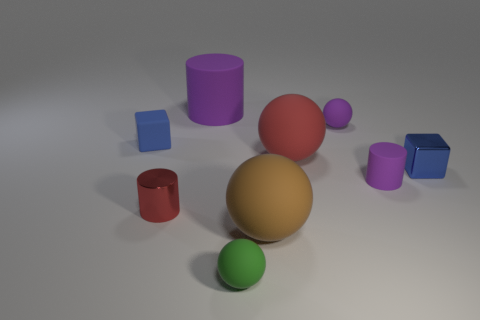Does the red ball have the same size as the brown object?
Your answer should be very brief. Yes. What number of things are purple rubber spheres or things that are behind the blue metallic object?
Ensure brevity in your answer.  4. What material is the tiny red object?
Give a very brief answer. Metal. Do the red rubber thing and the tiny blue rubber object have the same shape?
Keep it short and to the point. No. What size is the rubber cylinder behind the small rubber block that is behind the cylinder right of the brown rubber ball?
Offer a terse response. Large. How many other things are made of the same material as the red cylinder?
Offer a very short reply. 1. What color is the rubber object to the right of the purple ball?
Keep it short and to the point. Purple. There is a tiny block in front of the red matte ball that is left of the purple matte thing that is in front of the big red matte object; what is it made of?
Offer a terse response. Metal. Are there any other things of the same shape as the blue rubber object?
Your response must be concise. Yes. There is a green thing that is the same size as the shiny cylinder; what shape is it?
Provide a succinct answer. Sphere. 